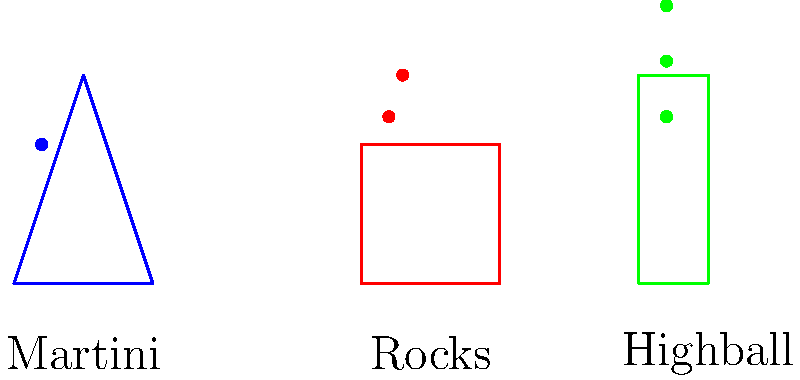As a bartender, you're experimenting with ice dilution rates in different glass shapes. You have a martini glass, a rocks glass, and a highball glass, each containing the same volume of liquid ($200$ mL) but different quantities of standard ice cubes ($2.5$ cm x $2.5$ cm x $2.5$ cm). The martini glass has $1$ cube, the rocks glass has $2$ cubes, and the highball glass has $3$ cubes. If the surface area of ice exposed to liquid affects the dilution rate, and assuming all other factors are constant, calculate the ratio of dilution rates between the highball and martini glasses after $5$ minutes. Let's approach this step-by-step:

1) First, we need to calculate the surface area of ice exposed in each glass:

   - One ice cube has 6 faces, each $2.5$ cm x $2.5$ cm = $6.25$ cm²
   - Total surface area of one cube = $6 \times 6.25$ cm² = $37.5$ cm²

2) Now, let's calculate the exposed surface area for each glass:

   - Martini glass: $1$ cube = $37.5$ cm²
   - Rocks glass: $2$ cubes = $75$ cm²
   - Highball glass: $3$ cubes = $112.5$ cm²

3) The dilution rate is proportional to the exposed surface area of ice. Let's call the dilution rate $D$ and the surface area $A$:

   $D \propto A$

4) To find the ratio of dilution rates between the highball and martini glasses:

   $\frac{D_{highball}}{D_{martini}} = \frac{A_{highball}}{A_{martini}} = \frac{112.5}{37.5} = 3$

5) This means the highball glass will have a dilution rate 3 times faster than the martini glass.
Answer: $3:1$ 